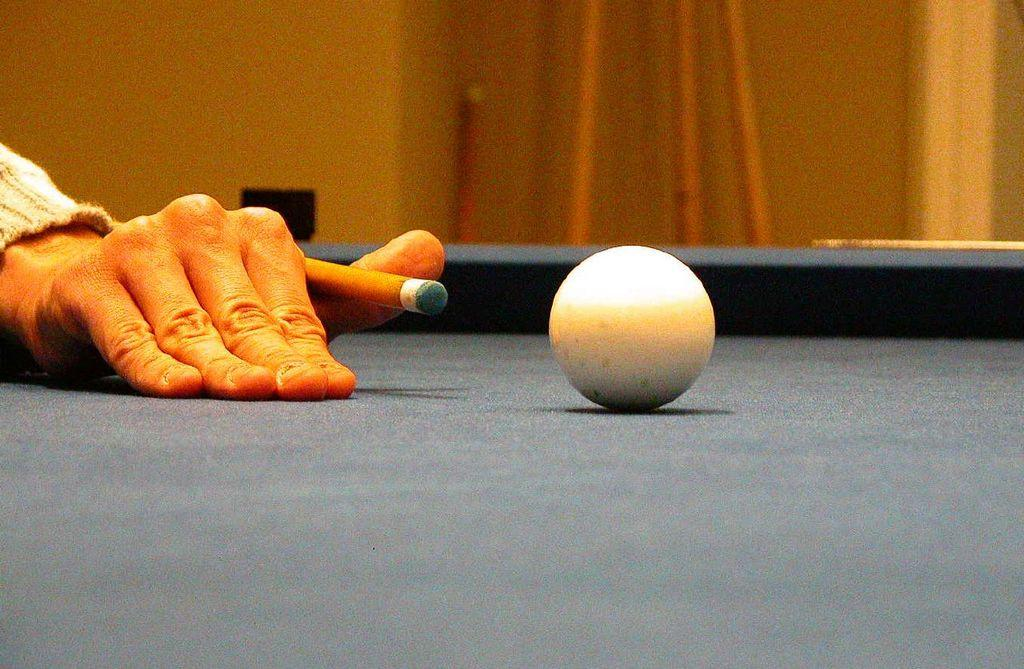What is the main object in the image? There is a pool table in the image. What is on top of the pool table? There is a ball on the pool table. Can you describe any human involvement in the image? Yes, there is a hand in the image. What can be said about the background of the image? The background of the image is blurred. What type of berry is being held by the hand in the image? There is no berry present in the image; the hand is not holding any berry. Can you describe the turkey that is sitting on the pool table in the image? There is no turkey present in the image; the pool table only has a ball on it. 